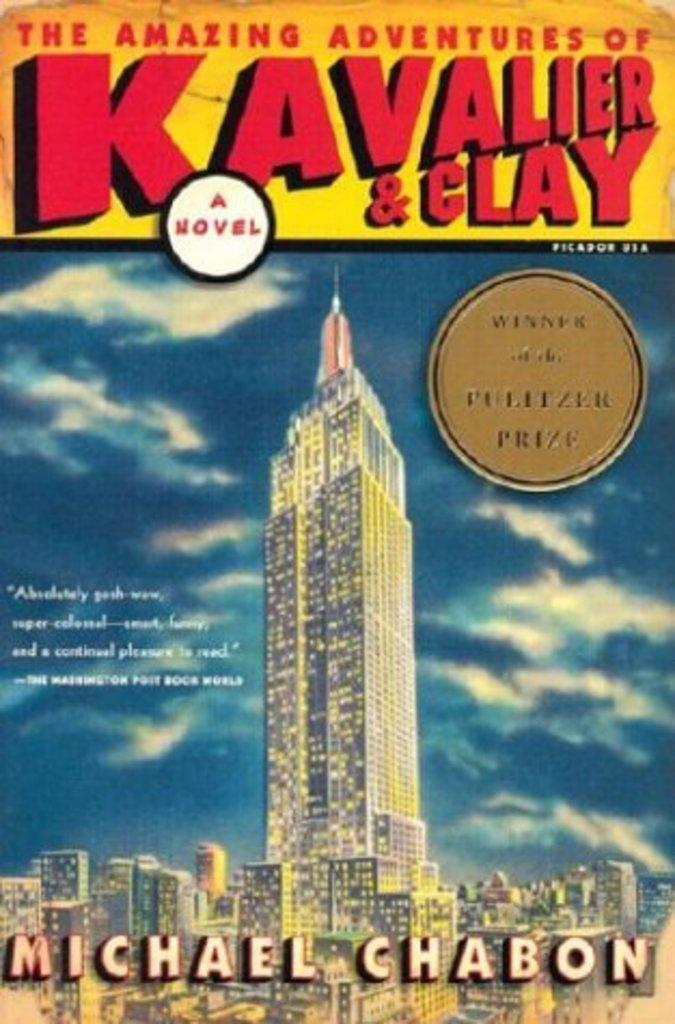What is featured on the poster in the picture? There is a poster in the picture, which has words and an image of buildings on it. What can be seen in the sky on the poster? The sky is visible in the image on the poster. How many baby clocks can be seen in the market on the poster? There are no baby clocks or a market depicted on the poster; it features an image of buildings and the sky. 